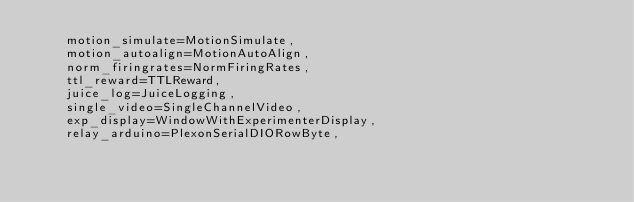Convert code to text. <code><loc_0><loc_0><loc_500><loc_500><_Python_>    motion_simulate=MotionSimulate,
    motion_autoalign=MotionAutoAlign,
    norm_firingrates=NormFiringRates,
    ttl_reward=TTLReward,
    juice_log=JuiceLogging,
    single_video=SingleChannelVideo,
    exp_display=WindowWithExperimenterDisplay,
    relay_arduino=PlexonSerialDIORowByte,</code> 